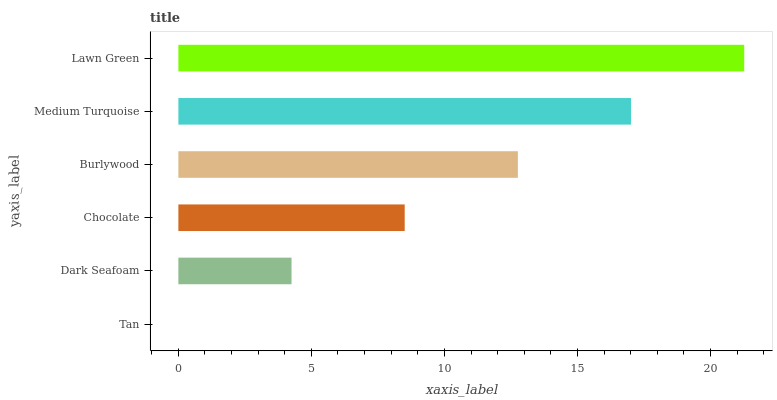Is Tan the minimum?
Answer yes or no. Yes. Is Lawn Green the maximum?
Answer yes or no. Yes. Is Dark Seafoam the minimum?
Answer yes or no. No. Is Dark Seafoam the maximum?
Answer yes or no. No. Is Dark Seafoam greater than Tan?
Answer yes or no. Yes. Is Tan less than Dark Seafoam?
Answer yes or no. Yes. Is Tan greater than Dark Seafoam?
Answer yes or no. No. Is Dark Seafoam less than Tan?
Answer yes or no. No. Is Burlywood the high median?
Answer yes or no. Yes. Is Chocolate the low median?
Answer yes or no. Yes. Is Tan the high median?
Answer yes or no. No. Is Medium Turquoise the low median?
Answer yes or no. No. 